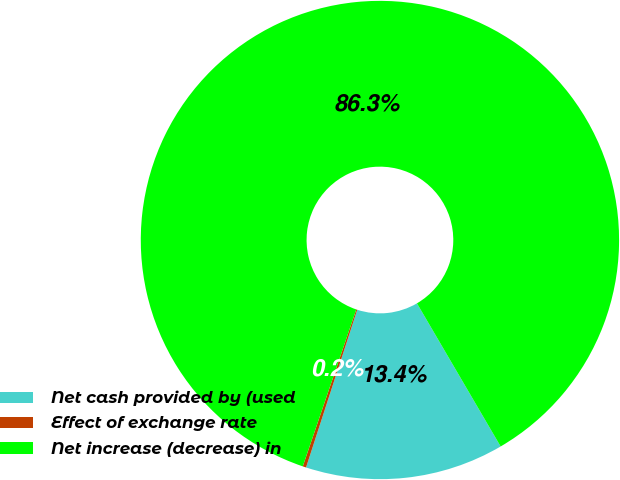Convert chart. <chart><loc_0><loc_0><loc_500><loc_500><pie_chart><fcel>Net cash provided by (used<fcel>Effect of exchange rate<fcel>Net increase (decrease) in<nl><fcel>13.42%<fcel>0.23%<fcel>86.35%<nl></chart> 